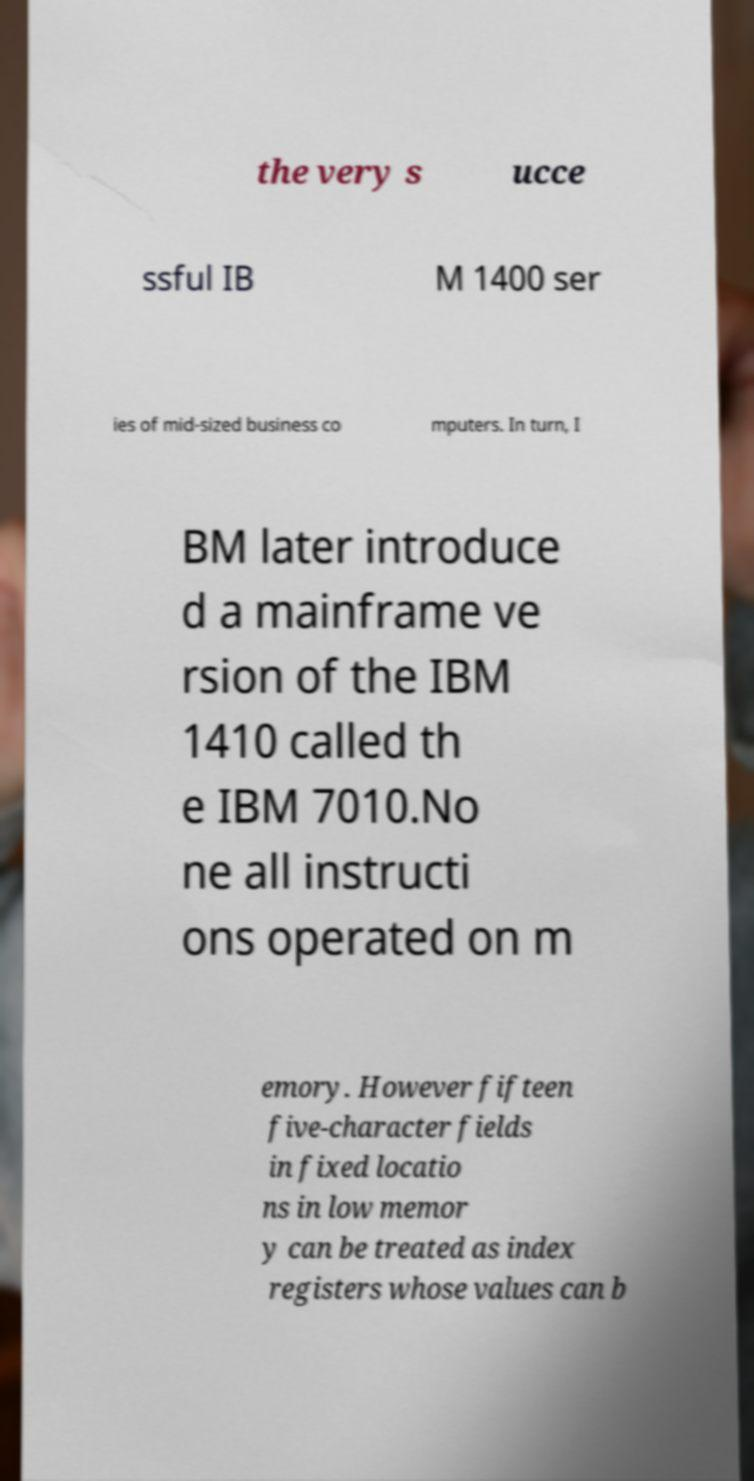Could you extract and type out the text from this image? the very s ucce ssful IB M 1400 ser ies of mid-sized business co mputers. In turn, I BM later introduce d a mainframe ve rsion of the IBM 1410 called th e IBM 7010.No ne all instructi ons operated on m emory. However fifteen five-character fields in fixed locatio ns in low memor y can be treated as index registers whose values can b 